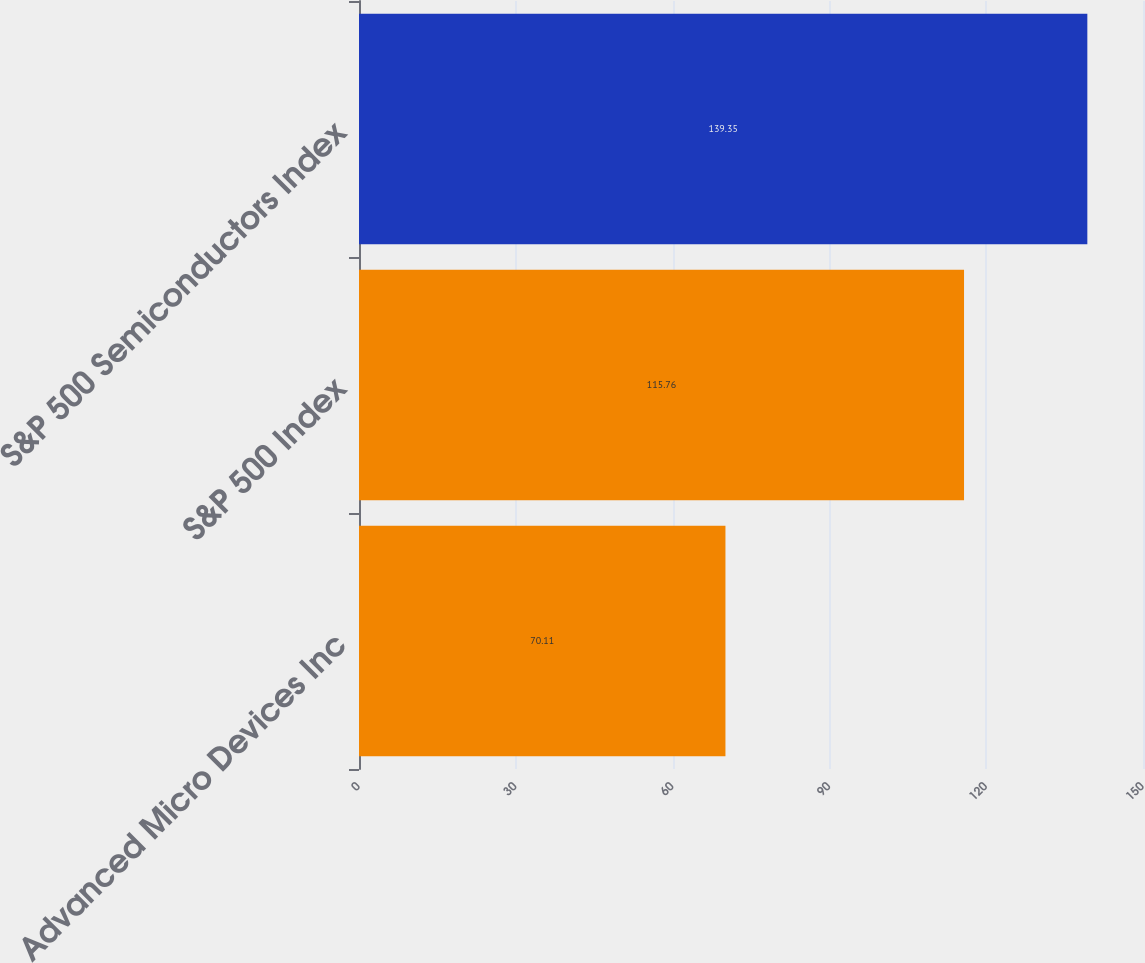Convert chart to OTSL. <chart><loc_0><loc_0><loc_500><loc_500><bar_chart><fcel>Advanced Micro Devices Inc<fcel>S&P 500 Index<fcel>S&P 500 Semiconductors Index<nl><fcel>70.11<fcel>115.76<fcel>139.35<nl></chart> 